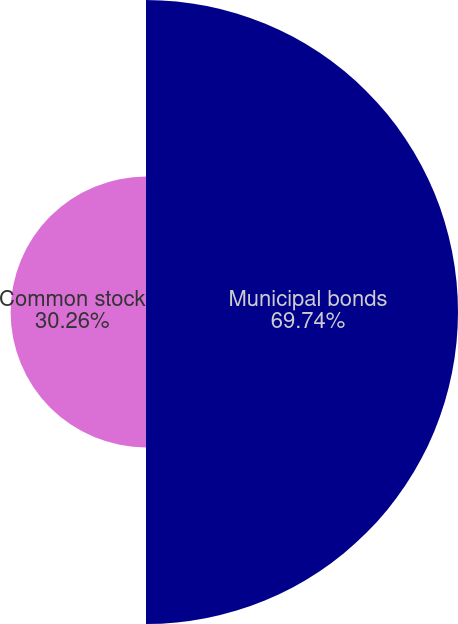Convert chart. <chart><loc_0><loc_0><loc_500><loc_500><pie_chart><fcel>Municipal bonds<fcel>Common stock<nl><fcel>69.74%<fcel>30.26%<nl></chart> 